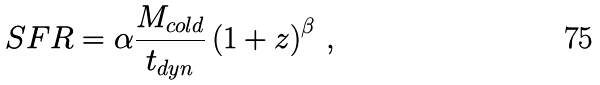Convert formula to latex. <formula><loc_0><loc_0><loc_500><loc_500>S F R = \alpha \frac { M _ { c o l d } } { t _ { d y n } } \left ( 1 + z \right ) ^ { \beta } \, ,</formula> 